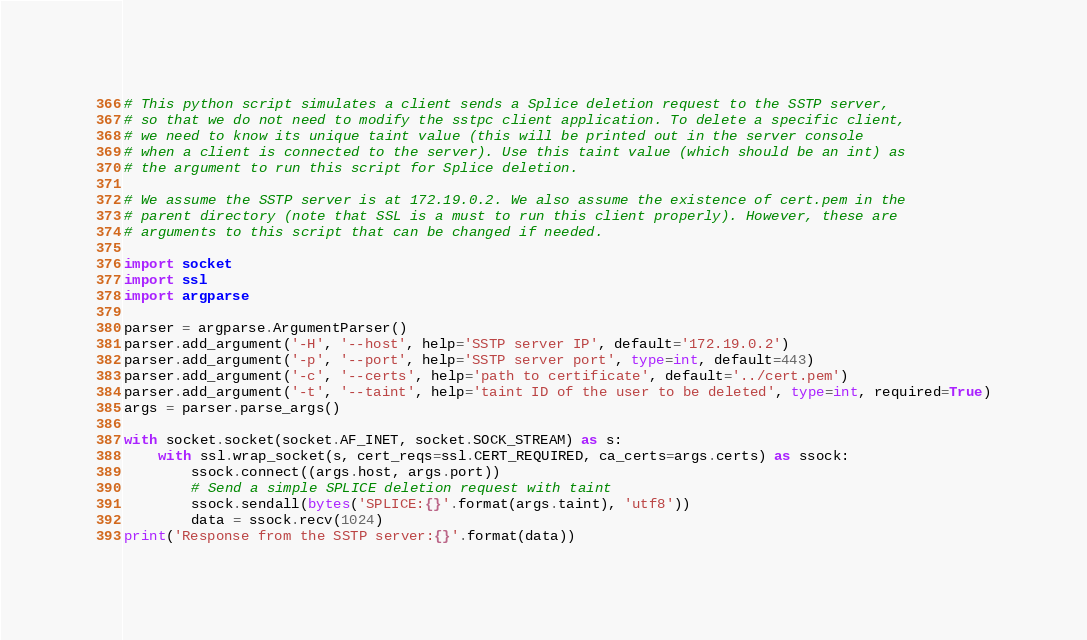<code> <loc_0><loc_0><loc_500><loc_500><_Python_># This python script simulates a client sends a Splice deletion request to the SSTP server,
# so that we do not need to modify the sstpc client application. To delete a specific client,
# we need to know its unique taint value (this will be printed out in the server console
# when a client is connected to the server). Use this taint value (which should be an int) as
# the argument to run this script for Splice deletion.

# We assume the SSTP server is at 172.19.0.2. We also assume the existence of cert.pem in the
# parent directory (note that SSL is a must to run this client properly). However, these are
# arguments to this script that can be changed if needed.

import socket
import ssl
import argparse

parser = argparse.ArgumentParser()
parser.add_argument('-H', '--host', help='SSTP server IP', default='172.19.0.2')
parser.add_argument('-p', '--port', help='SSTP server port', type=int, default=443)
parser.add_argument('-c', '--certs', help='path to certificate', default='../cert.pem')
parser.add_argument('-t', '--taint', help='taint ID of the user to be deleted', type=int, required=True)
args = parser.parse_args()

with socket.socket(socket.AF_INET, socket.SOCK_STREAM) as s:
    with ssl.wrap_socket(s, cert_reqs=ssl.CERT_REQUIRED, ca_certs=args.certs) as ssock:
        ssock.connect((args.host, args.port))
        # Send a simple SPLICE deletion request with taint
        ssock.sendall(bytes('SPLICE:{}'.format(args.taint), 'utf8'))
        data = ssock.recv(1024)
print('Response from the SSTP server:{}'.format(data))
</code> 